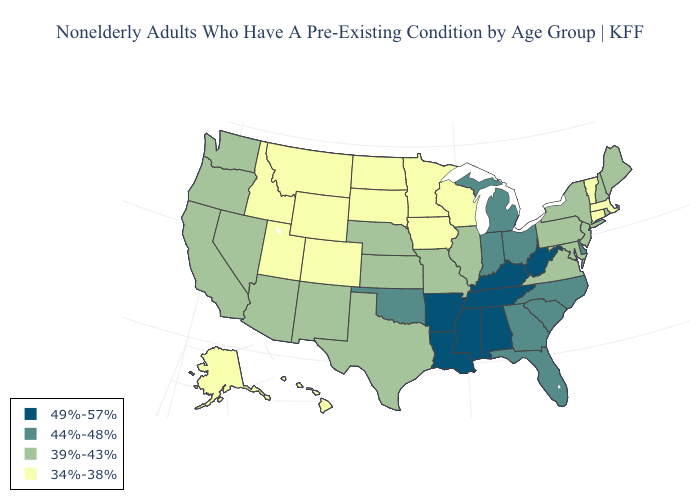What is the value of Massachusetts?
Be succinct. 34%-38%. Name the states that have a value in the range 44%-48%?
Answer briefly. Delaware, Florida, Georgia, Indiana, Michigan, North Carolina, Ohio, Oklahoma, South Carolina. Name the states that have a value in the range 34%-38%?
Answer briefly. Alaska, Colorado, Connecticut, Hawaii, Idaho, Iowa, Massachusetts, Minnesota, Montana, North Dakota, South Dakota, Utah, Vermont, Wisconsin, Wyoming. Name the states that have a value in the range 44%-48%?
Be succinct. Delaware, Florida, Georgia, Indiana, Michigan, North Carolina, Ohio, Oklahoma, South Carolina. What is the value of Maryland?
Keep it brief. 39%-43%. What is the value of Pennsylvania?
Be succinct. 39%-43%. Which states hav the highest value in the West?
Answer briefly. Arizona, California, Nevada, New Mexico, Oregon, Washington. What is the value of Rhode Island?
Be succinct. 39%-43%. Does Florida have a lower value than Kentucky?
Give a very brief answer. Yes. Which states have the lowest value in the USA?
Write a very short answer. Alaska, Colorado, Connecticut, Hawaii, Idaho, Iowa, Massachusetts, Minnesota, Montana, North Dakota, South Dakota, Utah, Vermont, Wisconsin, Wyoming. What is the value of Florida?
Write a very short answer. 44%-48%. Is the legend a continuous bar?
Give a very brief answer. No. What is the lowest value in the South?
Give a very brief answer. 39%-43%. What is the value of Texas?
Concise answer only. 39%-43%. Which states have the highest value in the USA?
Keep it brief. Alabama, Arkansas, Kentucky, Louisiana, Mississippi, Tennessee, West Virginia. 